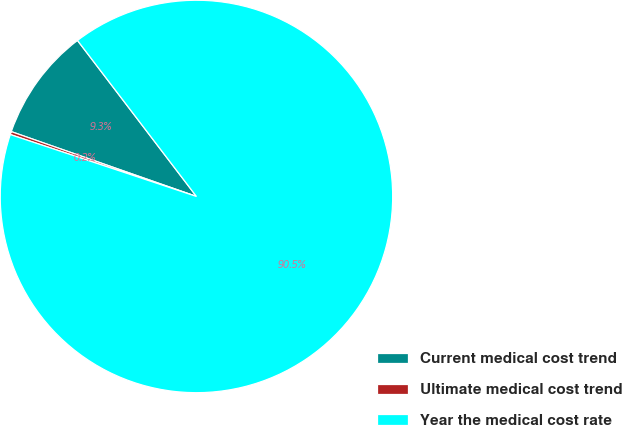Convert chart to OTSL. <chart><loc_0><loc_0><loc_500><loc_500><pie_chart><fcel>Current medical cost trend<fcel>Ultimate medical cost trend<fcel>Year the medical cost rate<nl><fcel>9.27%<fcel>0.25%<fcel>90.48%<nl></chart> 